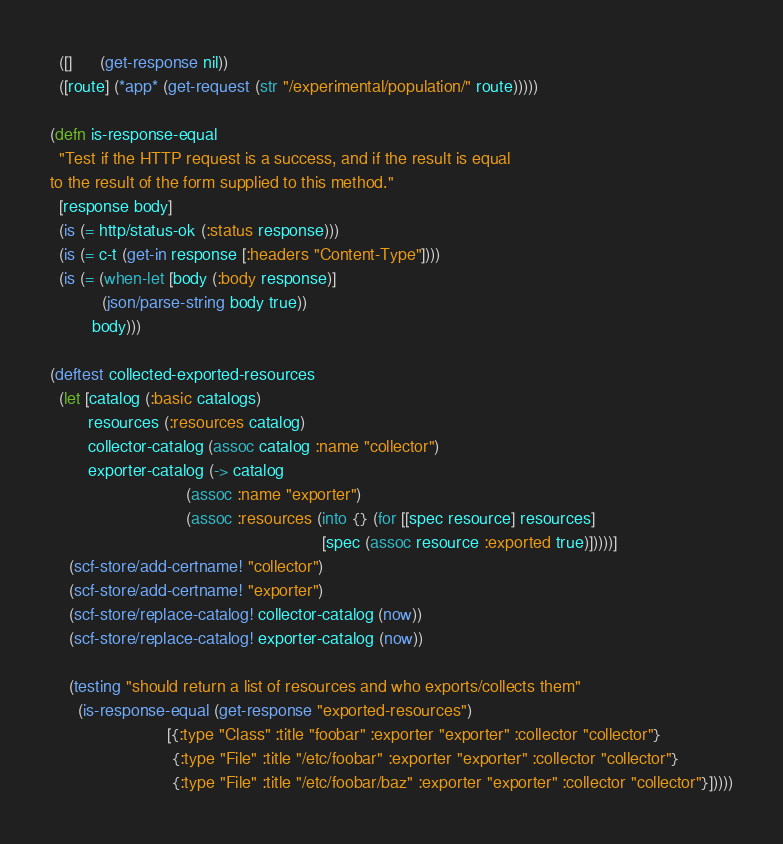<code> <loc_0><loc_0><loc_500><loc_500><_Clojure_>  ([]      (get-response nil))
  ([route] (*app* (get-request (str "/experimental/population/" route)))))

(defn is-response-equal
  "Test if the HTTP request is a success, and if the result is equal
to the result of the form supplied to this method."
  [response body]
  (is (= http/status-ok (:status response)))
  (is (= c-t (get-in response [:headers "Content-Type"])))
  (is (= (when-let [body (:body response)]
           (json/parse-string body true))
         body)))

(deftest collected-exported-resources
  (let [catalog (:basic catalogs)
        resources (:resources catalog)
        collector-catalog (assoc catalog :name "collector")
        exporter-catalog (-> catalog
                             (assoc :name "exporter")
                             (assoc :resources (into {} (for [[spec resource] resources]
                                                          [spec (assoc resource :exported true)]))))]
    (scf-store/add-certname! "collector")
    (scf-store/add-certname! "exporter")
    (scf-store/replace-catalog! collector-catalog (now))
    (scf-store/replace-catalog! exporter-catalog (now))

    (testing "should return a list of resources and who exports/collects them"
      (is-response-equal (get-response "exported-resources")
                         [{:type "Class" :title "foobar" :exporter "exporter" :collector "collector"}
                          {:type "File" :title "/etc/foobar" :exporter "exporter" :collector "collector"}
                          {:type "File" :title "/etc/foobar/baz" :exporter "exporter" :collector "collector"}]))))
</code> 